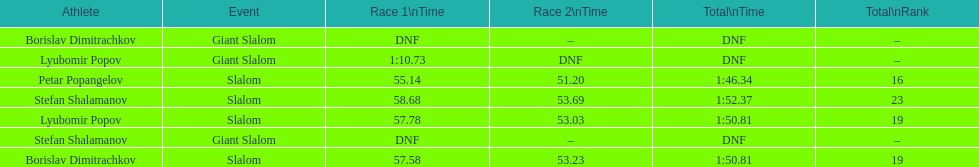Among the athletes, who had a race time of more than 1:00? Lyubomir Popov. I'm looking to parse the entire table for insights. Could you assist me with that? {'header': ['Athlete', 'Event', 'Race 1\\nTime', 'Race 2\\nTime', 'Total\\nTime', 'Total\\nRank'], 'rows': [['Borislav Dimitrachkov', 'Giant Slalom', 'DNF', '–', 'DNF', '–'], ['Lyubomir Popov', 'Giant Slalom', '1:10.73', 'DNF', 'DNF', '–'], ['Petar Popangelov', 'Slalom', '55.14', '51.20', '1:46.34', '16'], ['Stefan Shalamanov', 'Slalom', '58.68', '53.69', '1:52.37', '23'], ['Lyubomir Popov', 'Slalom', '57.78', '53.03', '1:50.81', '19'], ['Stefan Shalamanov', 'Giant Slalom', 'DNF', '–', 'DNF', '–'], ['Borislav Dimitrachkov', 'Slalom', '57.58', '53.23', '1:50.81', '19']]} 